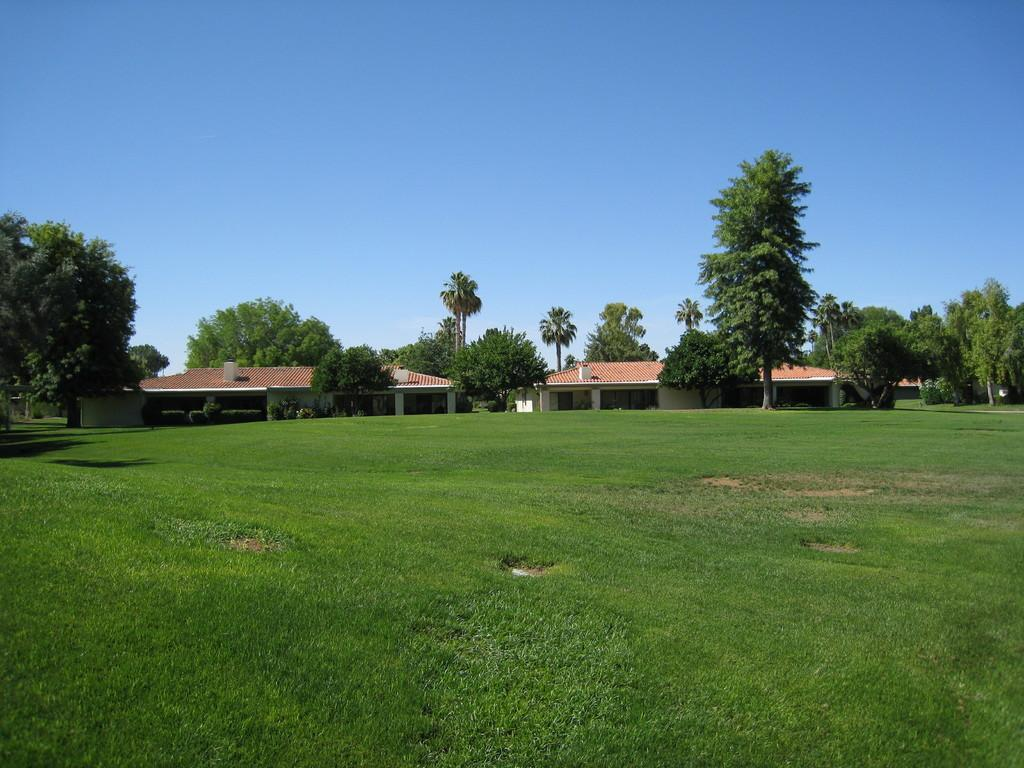What type of natural elements can be seen in the image? There are trees in the image. What type of man-made structures are present in the image? There are houses in the image. What is visible at the top of the image? The sky is visible at the top of the image. What is visible at the bottom of the image? The ground is visible at the bottom of the image. What type of business is being conducted in the image? There is no indication of any business activity in the image; it primarily features trees and houses. Is the image based on a fictional setting or story? The image does not appear to be based on a fictional setting or story; it depicts a natural and man-made environment. 